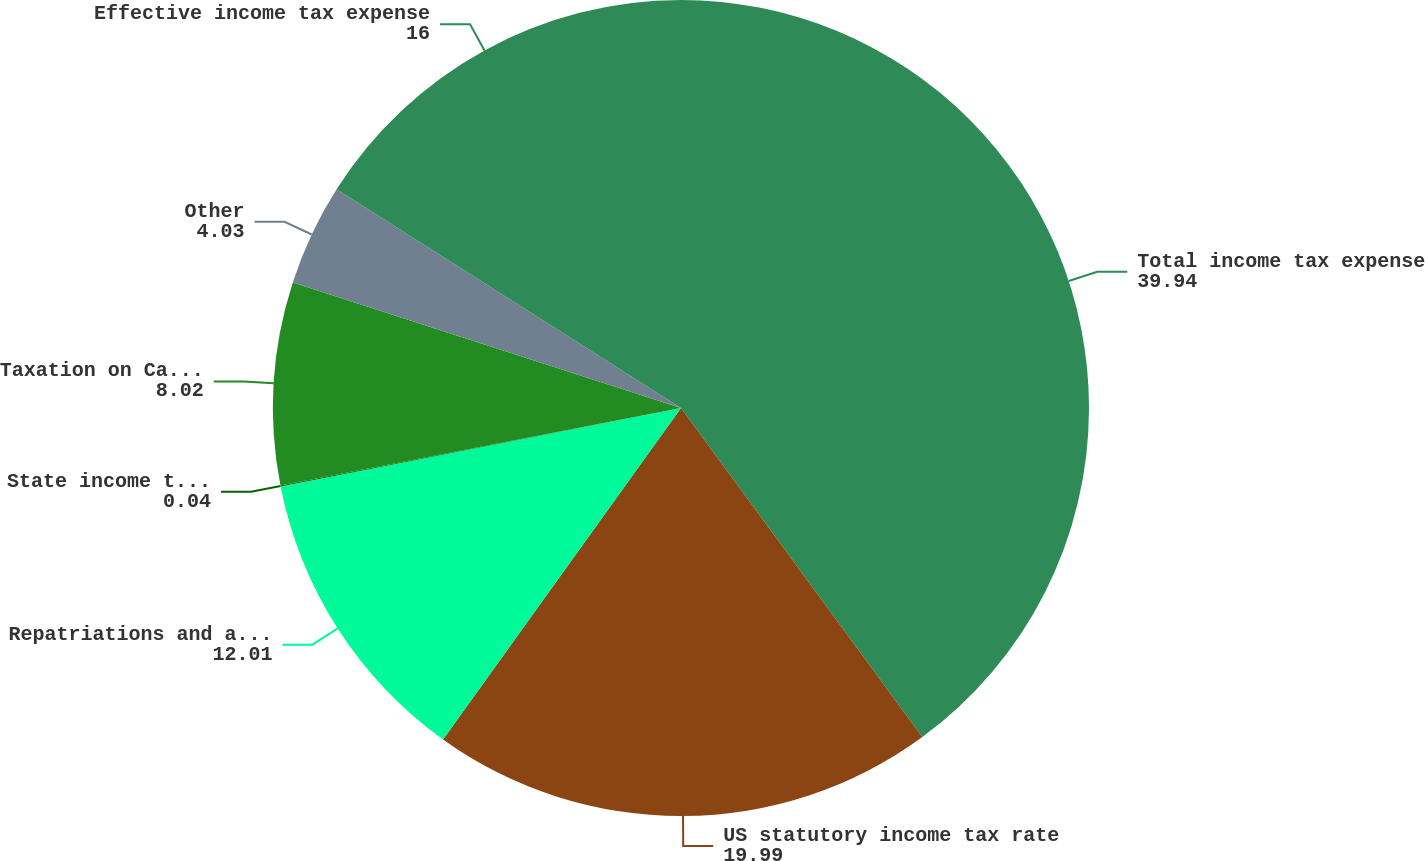Convert chart. <chart><loc_0><loc_0><loc_500><loc_500><pie_chart><fcel>Total income tax expense<fcel>US statutory income tax rate<fcel>Repatriations and assumed<fcel>State income taxes<fcel>Taxation on Canadian<fcel>Other<fcel>Effective income tax expense<nl><fcel>39.94%<fcel>19.99%<fcel>12.01%<fcel>0.04%<fcel>8.02%<fcel>4.03%<fcel>16.0%<nl></chart> 